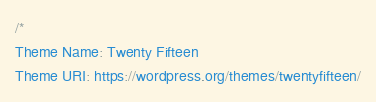Convert code to text. <code><loc_0><loc_0><loc_500><loc_500><_CSS_>/*
Theme Name: Twenty Fifteen
Theme URI: https://wordpress.org/themes/twentyfifteen/</code> 